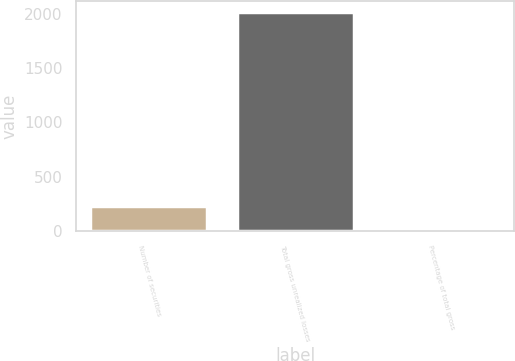Convert chart to OTSL. <chart><loc_0><loc_0><loc_500><loc_500><bar_chart><fcel>Number of securities<fcel>Total gross unrealized losses<fcel>Percentage of total gross<nl><fcel>229.3<fcel>2014<fcel>31<nl></chart> 